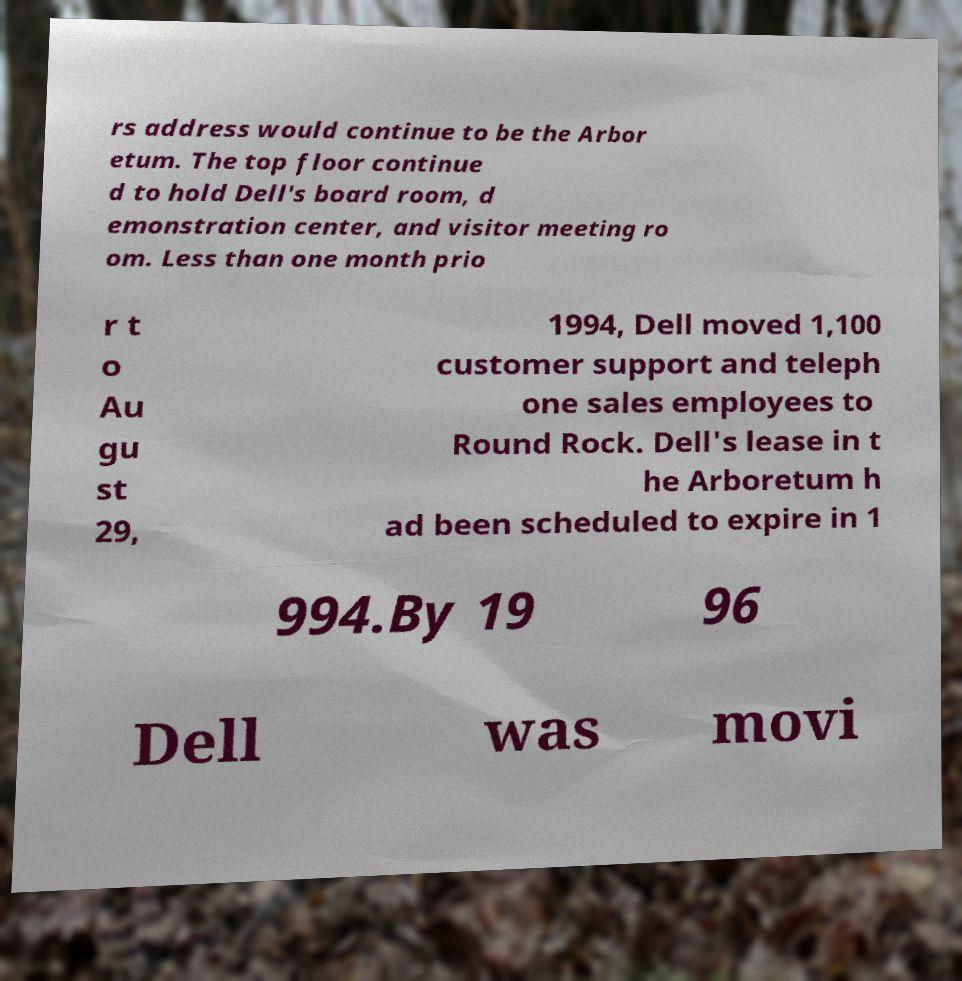There's text embedded in this image that I need extracted. Can you transcribe it verbatim? rs address would continue to be the Arbor etum. The top floor continue d to hold Dell's board room, d emonstration center, and visitor meeting ro om. Less than one month prio r t o Au gu st 29, 1994, Dell moved 1,100 customer support and teleph one sales employees to Round Rock. Dell's lease in t he Arboretum h ad been scheduled to expire in 1 994.By 19 96 Dell was movi 